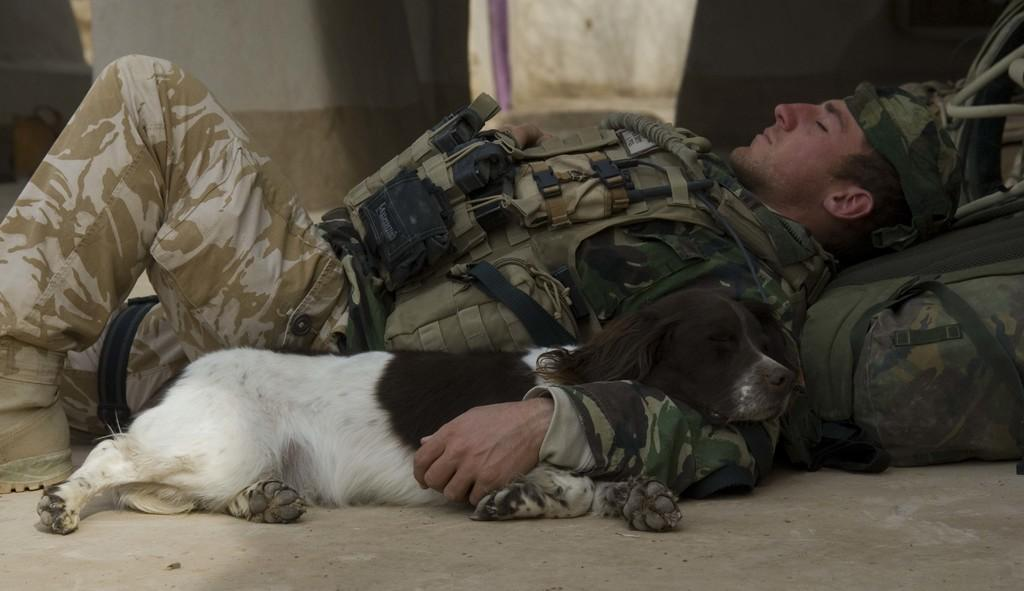What is the man doing in the image? The man is lying on the land in the middle of the image. What is the man holding in the image? The man is holding an animal in the image. What object can be seen on the right side of the image? There is a backpack on the right side of the image. What can be seen in the background of the image? There is a wall in the background of the image. What type of screw can be seen in the image? There is no screw present in the image. 